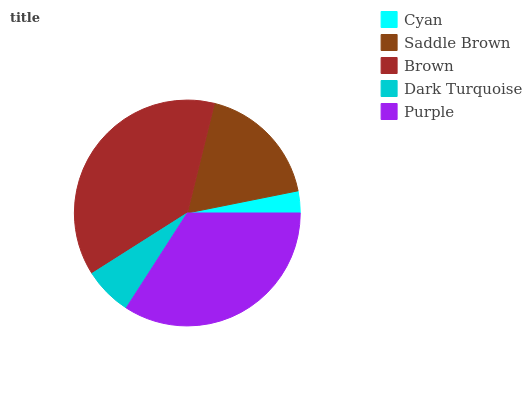Is Cyan the minimum?
Answer yes or no. Yes. Is Brown the maximum?
Answer yes or no. Yes. Is Saddle Brown the minimum?
Answer yes or no. No. Is Saddle Brown the maximum?
Answer yes or no. No. Is Saddle Brown greater than Cyan?
Answer yes or no. Yes. Is Cyan less than Saddle Brown?
Answer yes or no. Yes. Is Cyan greater than Saddle Brown?
Answer yes or no. No. Is Saddle Brown less than Cyan?
Answer yes or no. No. Is Saddle Brown the high median?
Answer yes or no. Yes. Is Saddle Brown the low median?
Answer yes or no. Yes. Is Dark Turquoise the high median?
Answer yes or no. No. Is Purple the low median?
Answer yes or no. No. 